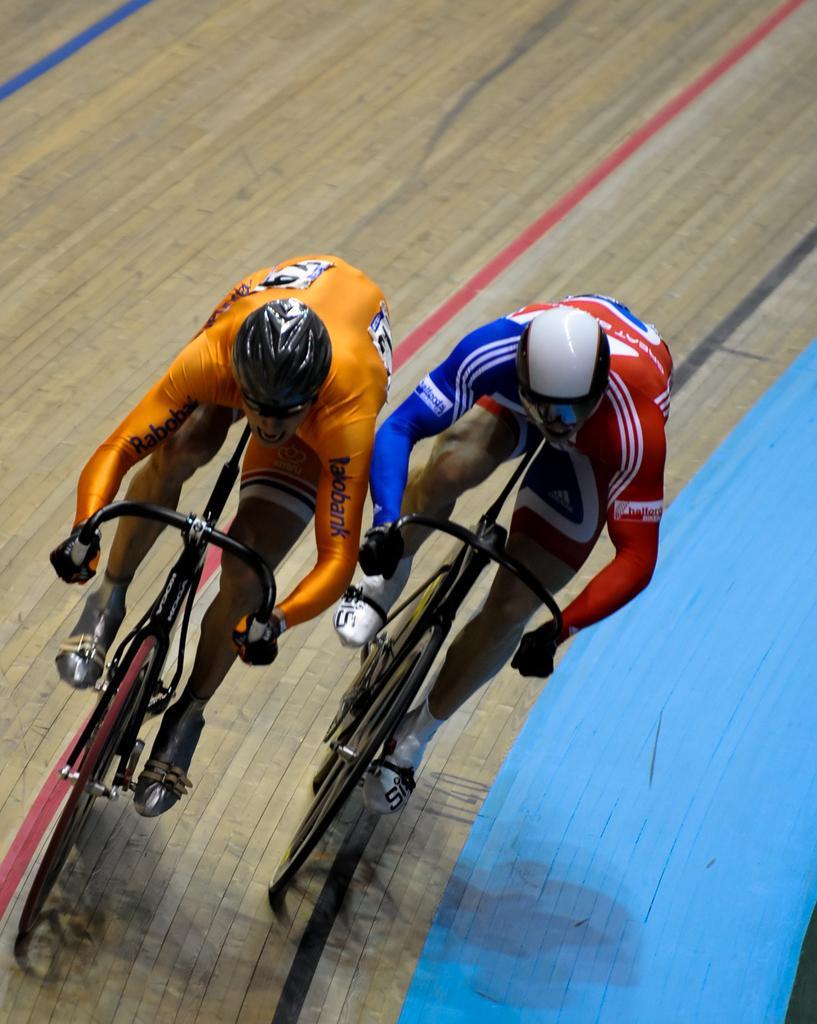Please provide a concise description of this image. In this picture, we can see two persons cycling on the racetrack. 